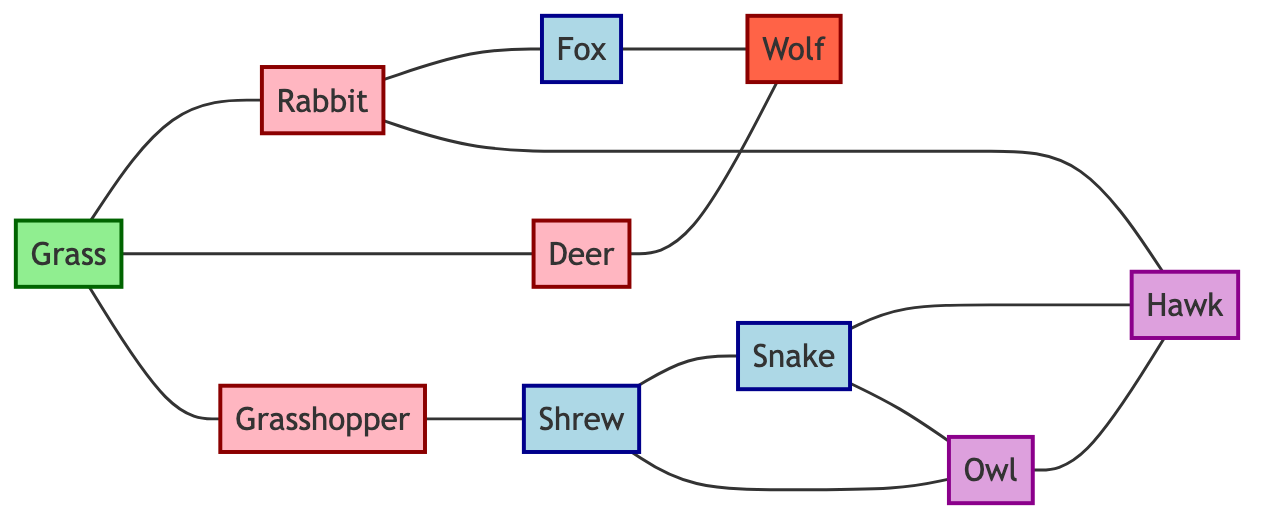What are the primary consumers in the food web? The diagram lists the nodes that are categorized as primary consumers, which are defined as those directly consuming producers. In this case, the primary consumers identified are Rabbit, Deer, and Grasshopper.
Answer: Rabbit, Deer, Grasshopper How many total nodes are there in the diagram? To find the total number of nodes, we count each distinct species listed under the "nodes" section of the data. There are ten species in total: Grass, Rabbit, Deer, Grasshopper, Fox, Hawk, Snake, Wolf, Shrew, and Owl.
Answer: 10 Which predator is connected to the Rabbit? The diagram shows two distinct connections from the Rabbit to other nodes. The Rabbit is connected to the Fox and the Hawk, both of which are considered predators in this context.
Answer: Fox, Hawk What type of consumer is the Wolf? The diagram categorizes the Wolf as an apex predator. This classification implies that it is at the top of the food web and has no natural predators.
Answer: Apex Predator How many edges are associated with the Shrew? To determine the number of edges connected to the Shrew, we review all connections leading to and from this node. The Shrew connects to three nodes: Grasshopper, Snake, and Owl, representing three edges.
Answer: 3 Which species is the primary producer in the food web? The primary producer in the diagram is Grass. Producers are the organisms that create energy through processes like photosynthesis, and in this case, Grass serves this role.
Answer: Grass How many tertiary consumers are in the diagram? The diagram highlights two species classified as tertiary consumers: Hawk and Owl. Tertiary consumers are those that eat secondary consumers, and in this specific case, there are two such organisms.
Answer: 2 Which species is the secondary consumer that preys on the Grasshopper? According to the diagram, the Shrew is a secondary consumer that preys on the Grasshopper. By examining the edges connected to the Grasshopper, we identify the Shrew as its predator.
Answer: Shrew What is the relationship between the Deer and the Wolf? The diagram shows a direct connection (edge) between the Deer and the Wolf, indicating that the Wolf preys on the Deer in this food web ecosystem.
Answer: Prey Do the Snake and the Owl have a direct connection? By analyzing the connections in the diagram, we can see that the Snake does indeed have a direct edge connecting it to the Owl. This suggests a predatory relationship where one may prey on the other.
Answer: Yes 